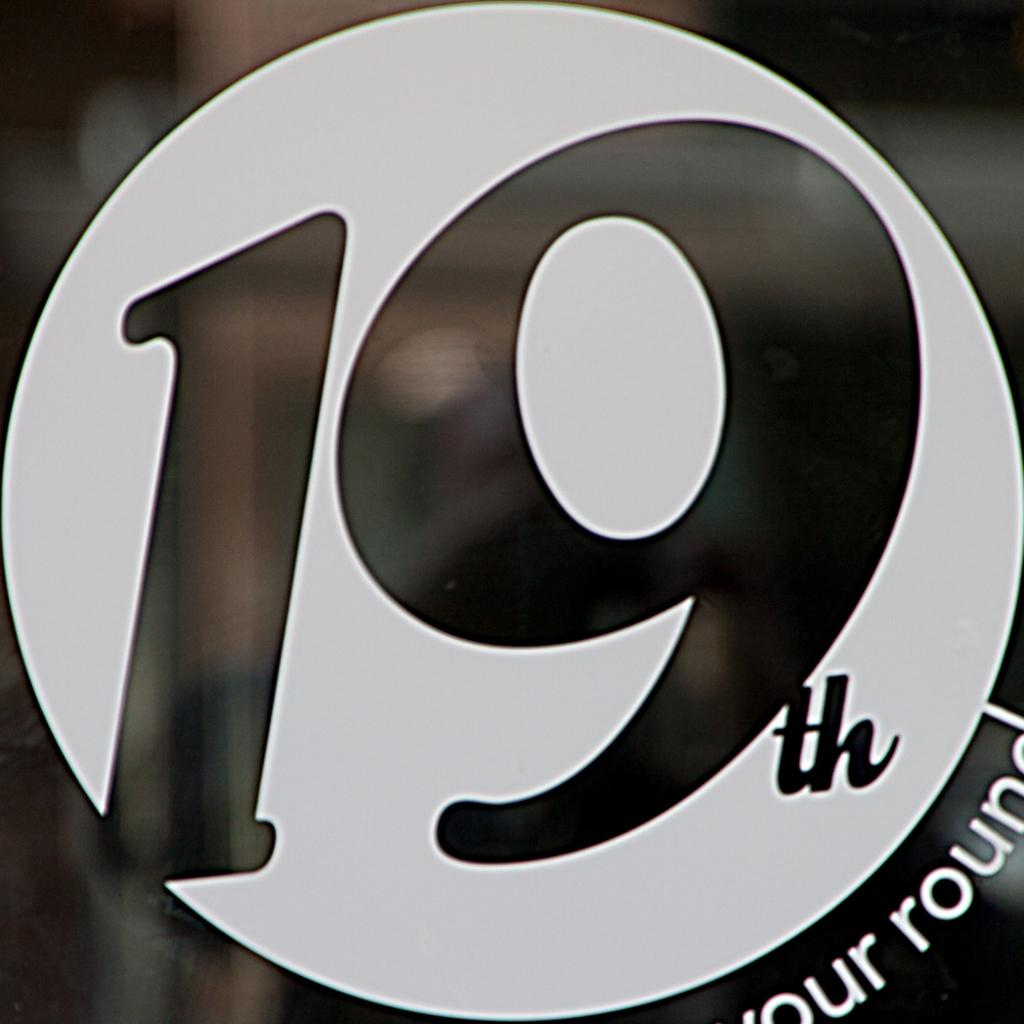What is the main object in the image? There is a board or poster in the image. What color scheme is used for the board or poster? The board or poster is in black and white. What number can be seen on the board or poster? The number 19 is written on the board or poster. What else is written on the board or poster? There is text written on the board or poster. What color is the background of the image? The background of the image is black. Can you see any oatmeal being prepared in the image? There is no oatmeal or any indication of food preparation in the image. Are there any creatures with fangs visible in the image? There are no creatures or fangs present in the image. 